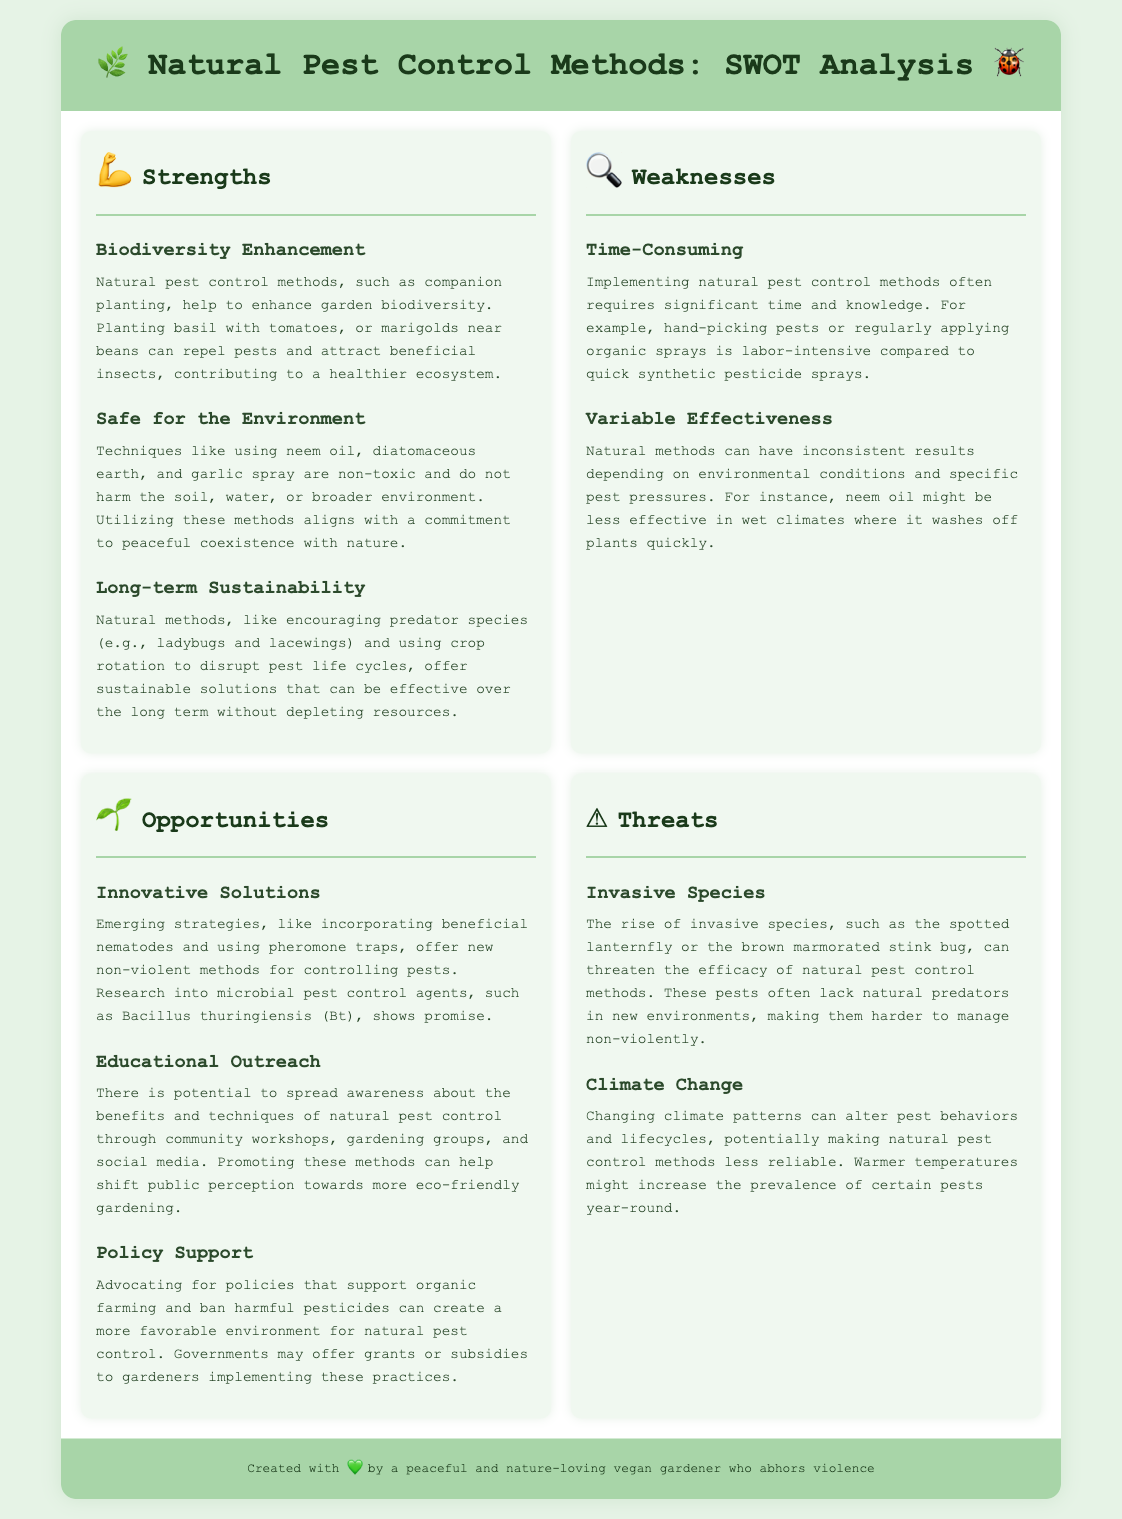What are some natural pest control methods? The document lists techniques such as companion planting, neem oil, diatomaceous earth, and garlic spray as natural pest control methods.
Answer: Companion planting, neem oil, diatomaceous earth, garlic spray What strength relates to biodiversity? The strength related to biodiversity is about companion planting which enhances garden biodiversity and attracts beneficial insects.
Answer: Biodiversity Enhancement What is one weakness of natural pest control methods? One weakness mentioned is that implementing natural pest control methods often requires significant time and knowledge.
Answer: Time-Consuming What opportunity involves new methods? The opportunity regarding new methods includes incorporating beneficial nematodes and using pheromone traps.
Answer: Innovative Solutions What threat is caused by non-native species? The rise of invasive species threatens the efficacy of natural pest control methods as they often lack natural predators.
Answer: Invasive Species How can climate change affect pest management? Changing climate patterns can alter pest behaviors and lifecycles, making natural pest control methods less reliable.
Answer: Climate Change What is a long-term advantage of natural methods? One long-term advantage of natural methods is that they offer sustainable solutions without depleting resources.
Answer: Long-term Sustainability Which section discusses the policy environment? The section that discusses policy environment is the Opportunities section, which talks about advocating for policies supporting organic farming.
Answer: Opportunities 